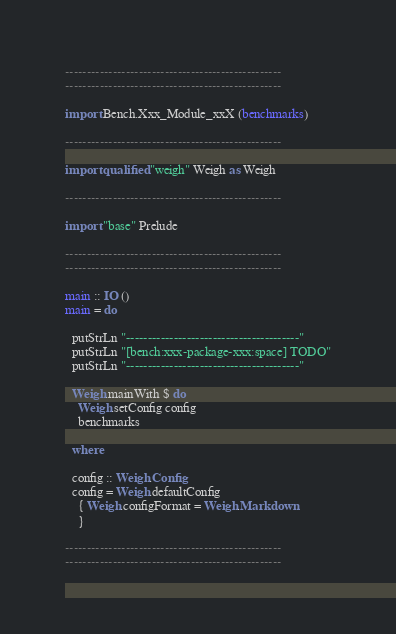Convert code to text. <code><loc_0><loc_0><loc_500><loc_500><_Haskell_>--------------------------------------------------
--------------------------------------------------

import Bench.Xxx_Module_xxX (benchmarks)

--------------------------------------------------

import qualified "weigh" Weigh as Weigh

--------------------------------------------------

import "base" Prelude

--------------------------------------------------
--------------------------------------------------

main :: IO ()
main = do

  putStrLn "----------------------------------------"
  putStrLn "[bench:xxx-package-xxx:space] TODO"
  putStrLn "----------------------------------------"

  Weigh.mainWith $ do
    Weigh.setConfig config
    benchmarks

  where

  config :: Weigh.Config
  config = Weigh.defaultConfig
    { Weigh.configFormat = Weigh.Markdown
    }

--------------------------------------------------
--------------------------------------------------</code> 